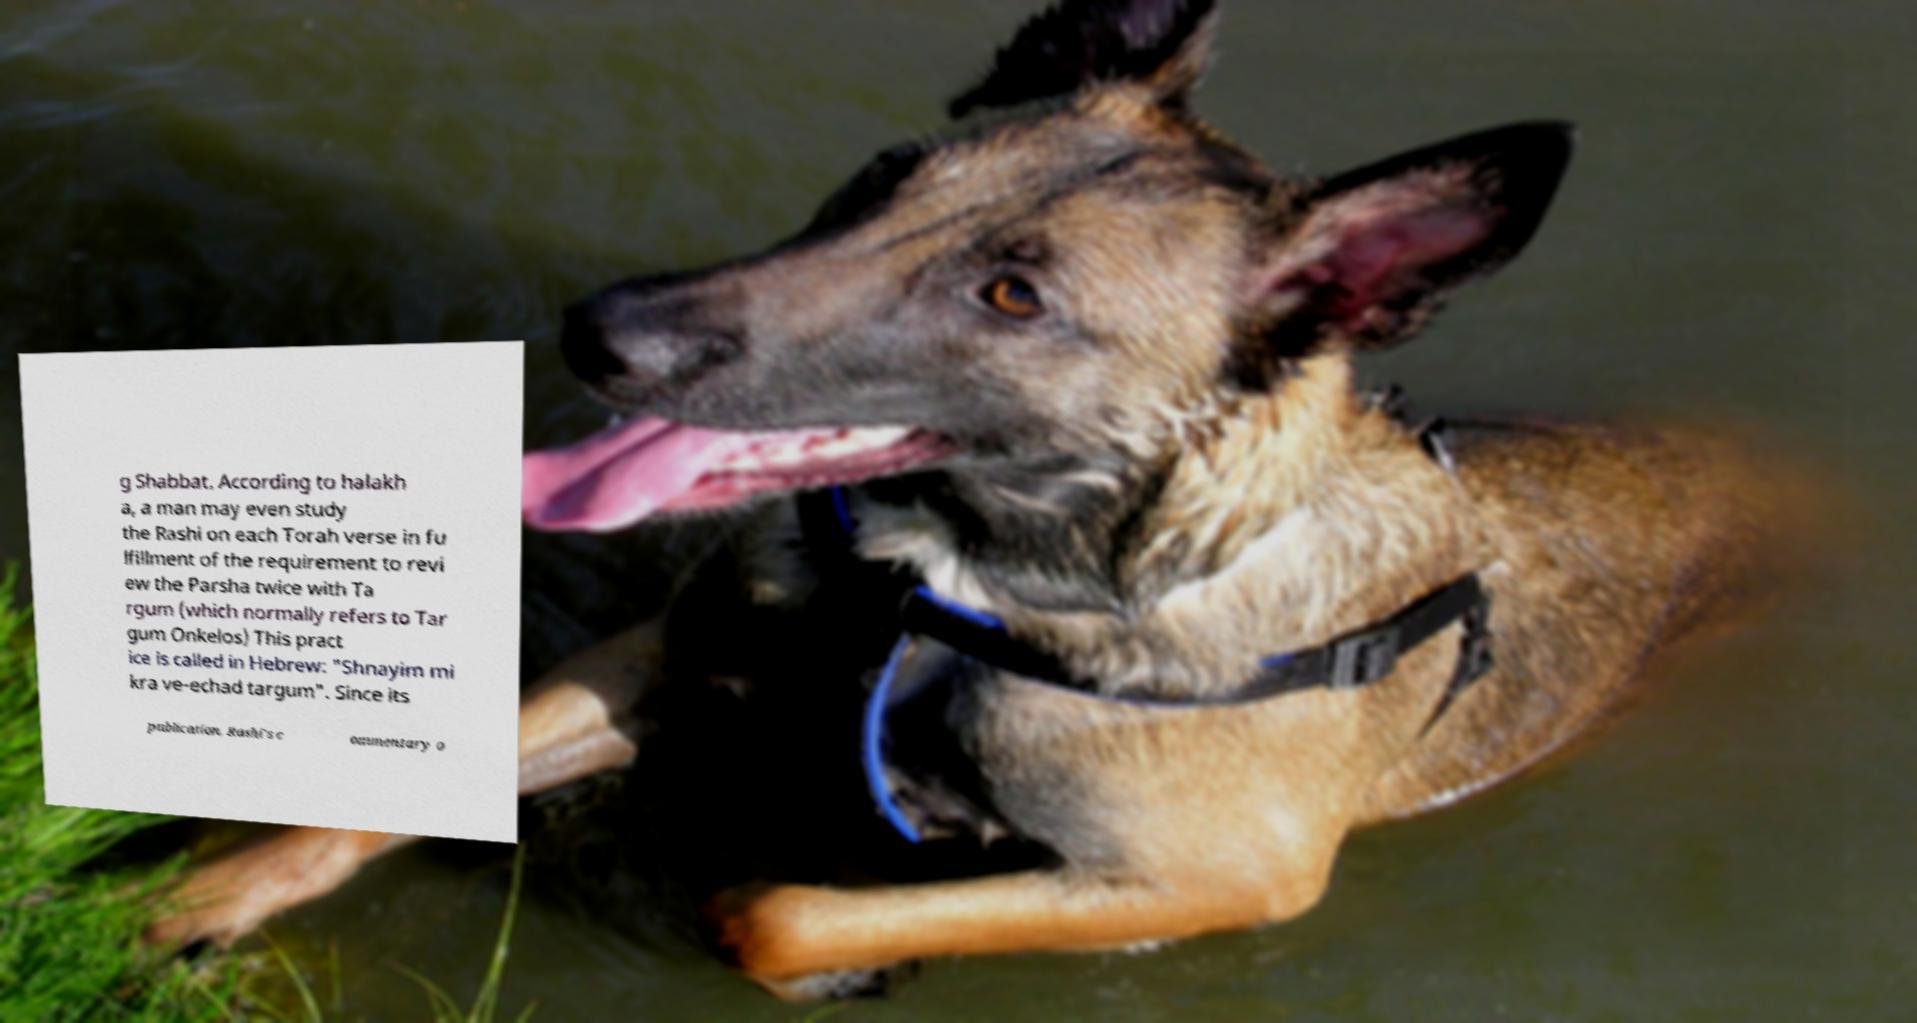Could you extract and type out the text from this image? g Shabbat. According to halakh a, a man may even study the Rashi on each Torah verse in fu lfillment of the requirement to revi ew the Parsha twice with Ta rgum (which normally refers to Tar gum Onkelos) This pract ice is called in Hebrew: "Shnayim mi kra ve-echad targum". Since its publication, Rashi's c ommentary o 